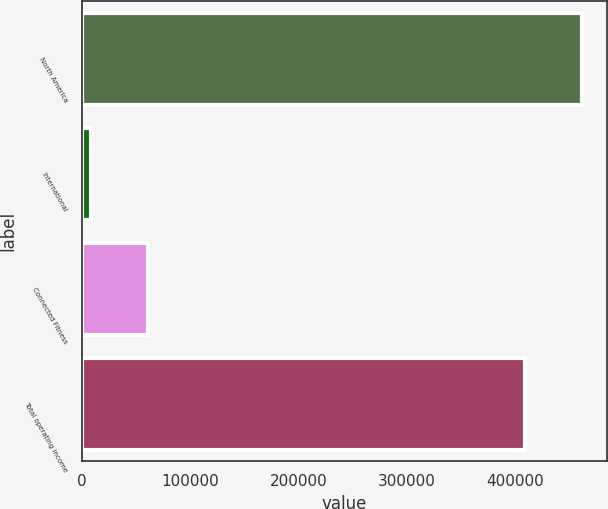Convert chart to OTSL. <chart><loc_0><loc_0><loc_500><loc_500><bar_chart><fcel>North America<fcel>International<fcel>Connected Fitness<fcel>Total operating income<nl><fcel>460961<fcel>8887<fcel>61301<fcel>408547<nl></chart> 